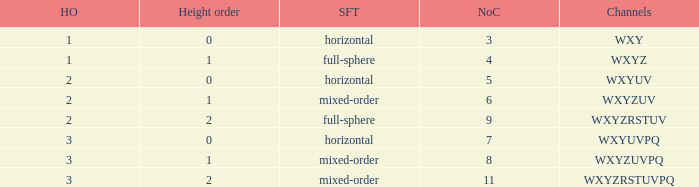If the height order is 1 and the soundfield type is mixed-order, what are all the channels? WXYZUV, WXYZUVPQ. 